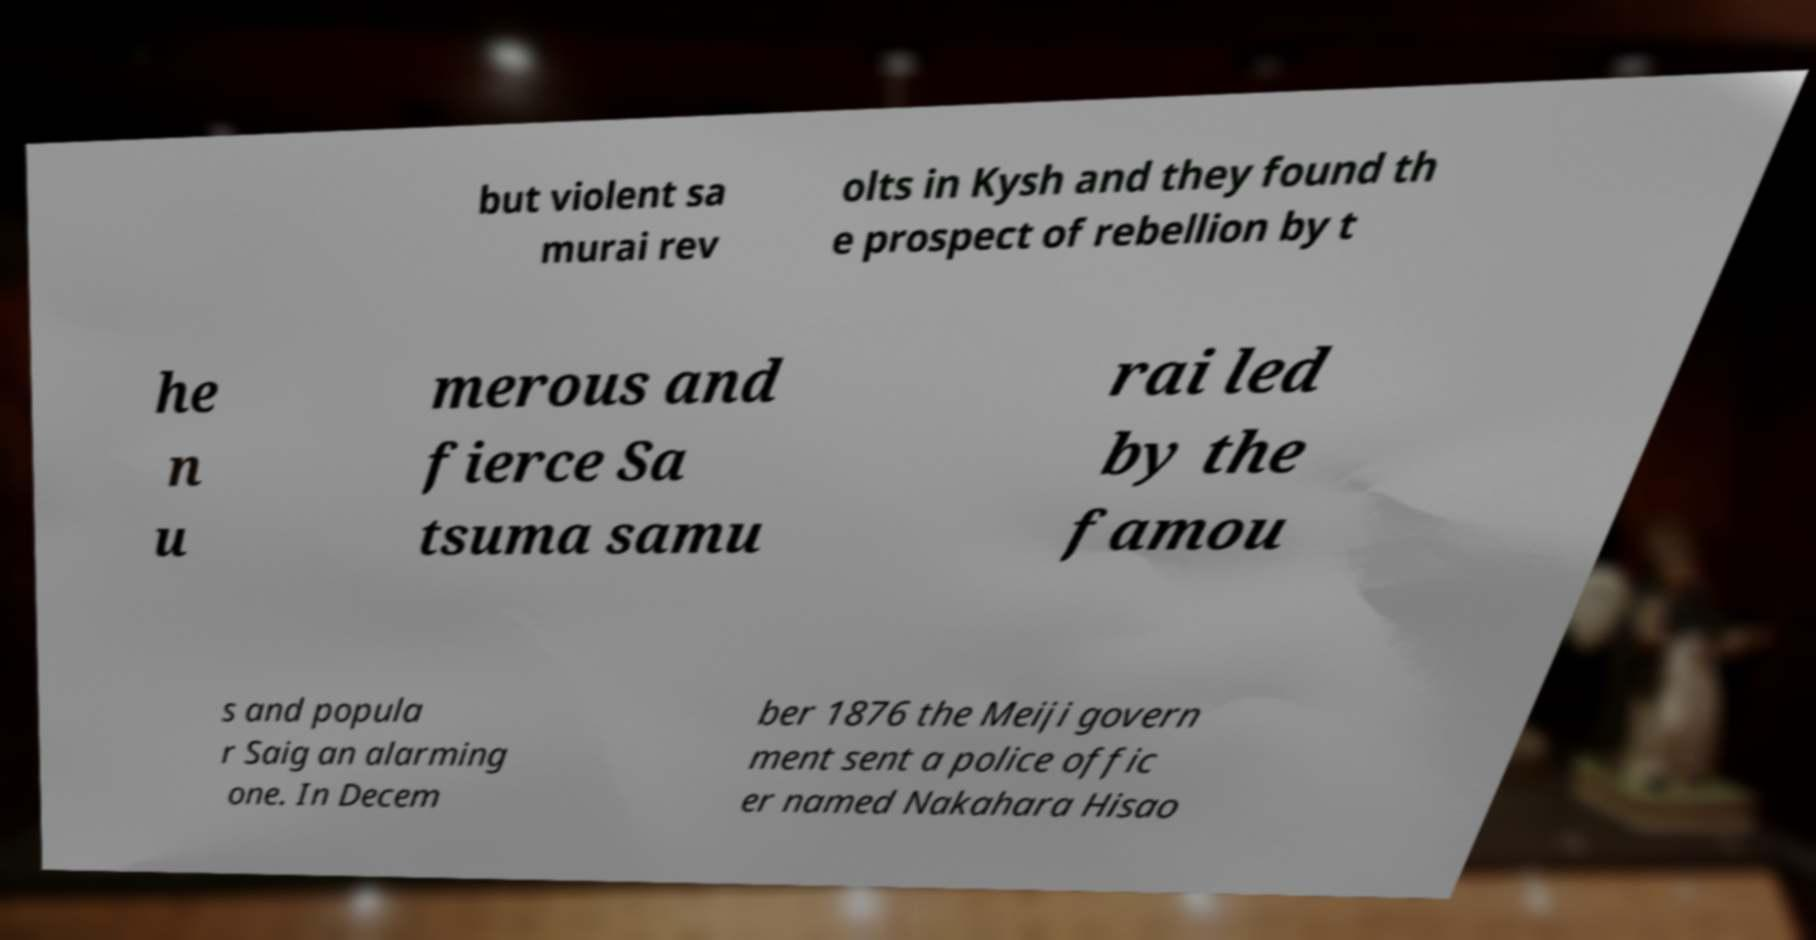Can you read and provide the text displayed in the image?This photo seems to have some interesting text. Can you extract and type it out for me? but violent sa murai rev olts in Kysh and they found th e prospect of rebellion by t he n u merous and fierce Sa tsuma samu rai led by the famou s and popula r Saig an alarming one. In Decem ber 1876 the Meiji govern ment sent a police offic er named Nakahara Hisao 